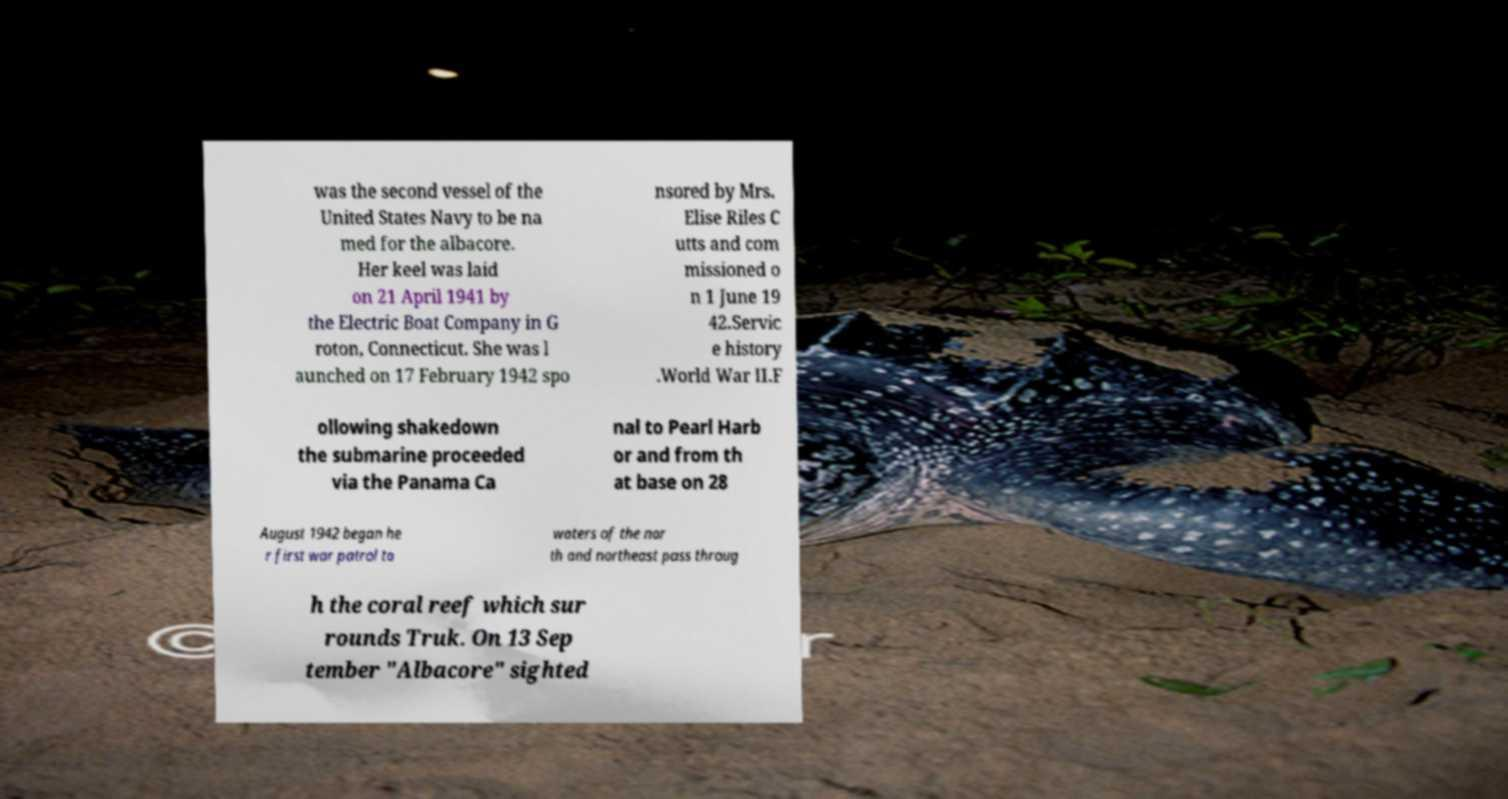Please identify and transcribe the text found in this image. was the second vessel of the United States Navy to be na med for the albacore. Her keel was laid on 21 April 1941 by the Electric Boat Company in G roton, Connecticut. She was l aunched on 17 February 1942 spo nsored by Mrs. Elise Riles C utts and com missioned o n 1 June 19 42.Servic e history .World War II.F ollowing shakedown the submarine proceeded via the Panama Ca nal to Pearl Harb or and from th at base on 28 August 1942 began he r first war patrol to waters of the nor th and northeast pass throug h the coral reef which sur rounds Truk. On 13 Sep tember "Albacore" sighted 